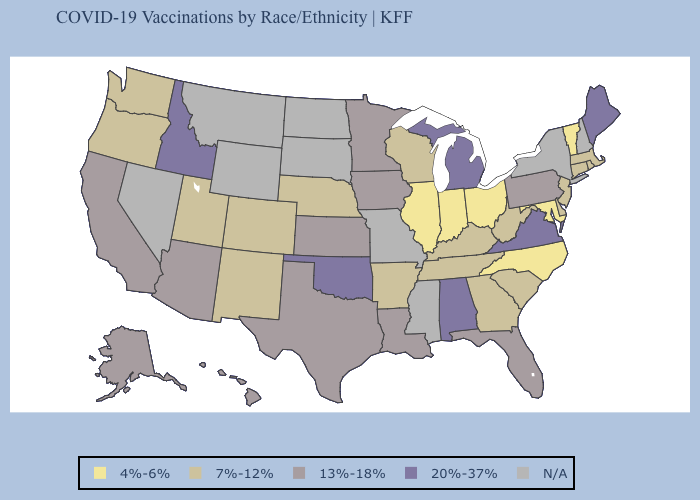Name the states that have a value in the range 13%-18%?
Short answer required. Alaska, Arizona, California, Florida, Hawaii, Iowa, Kansas, Louisiana, Minnesota, Pennsylvania, Texas. Does Illinois have the lowest value in the MidWest?
Be succinct. Yes. Among the states that border Kansas , does Nebraska have the highest value?
Quick response, please. No. What is the lowest value in the South?
Concise answer only. 4%-6%. Which states have the highest value in the USA?
Keep it brief. Alabama, Idaho, Maine, Michigan, Oklahoma, Virginia. What is the highest value in the USA?
Give a very brief answer. 20%-37%. What is the value of Georgia?
Answer briefly. 7%-12%. What is the lowest value in the South?
Give a very brief answer. 4%-6%. Name the states that have a value in the range 7%-12%?
Give a very brief answer. Arkansas, Colorado, Connecticut, Delaware, Georgia, Kentucky, Massachusetts, Nebraska, New Jersey, New Mexico, Oregon, Rhode Island, South Carolina, Tennessee, Utah, Washington, West Virginia, Wisconsin. Does Alabama have the highest value in the USA?
Be succinct. Yes. Does Vermont have the lowest value in the Northeast?
Keep it brief. Yes. What is the highest value in states that border Delaware?
Quick response, please. 13%-18%. Name the states that have a value in the range 20%-37%?
Short answer required. Alabama, Idaho, Maine, Michigan, Oklahoma, Virginia. 